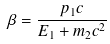<formula> <loc_0><loc_0><loc_500><loc_500>\beta = \frac { p _ { 1 } c } { E _ { 1 } + m _ { 2 } c ^ { 2 } }</formula> 